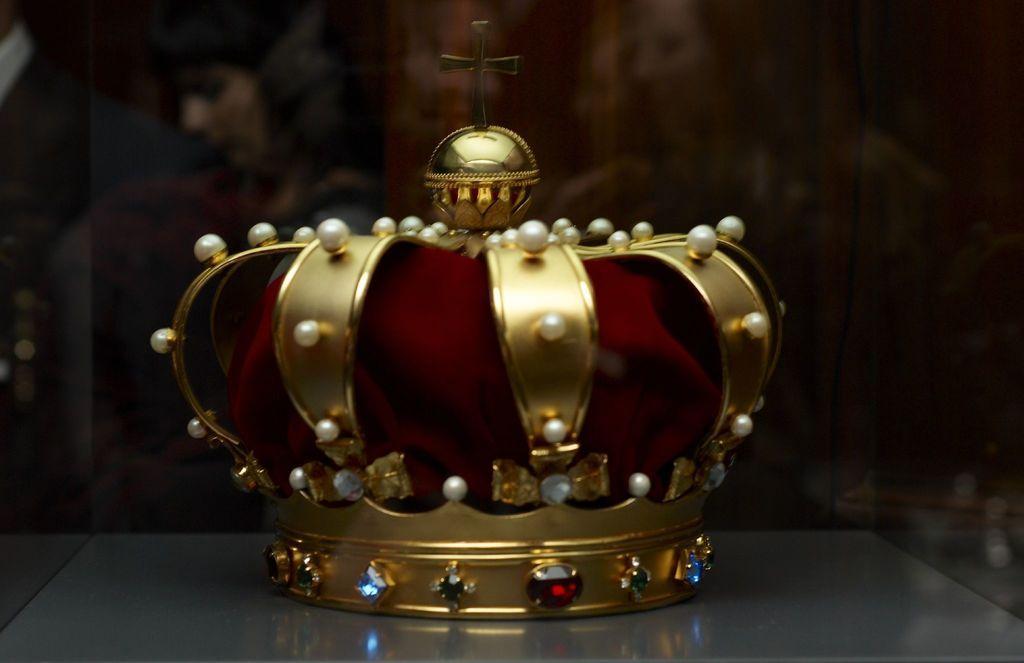Can you describe this image briefly? There is a crown in the center of the image and there is a plus sign on the top of it and the background area is blur. 